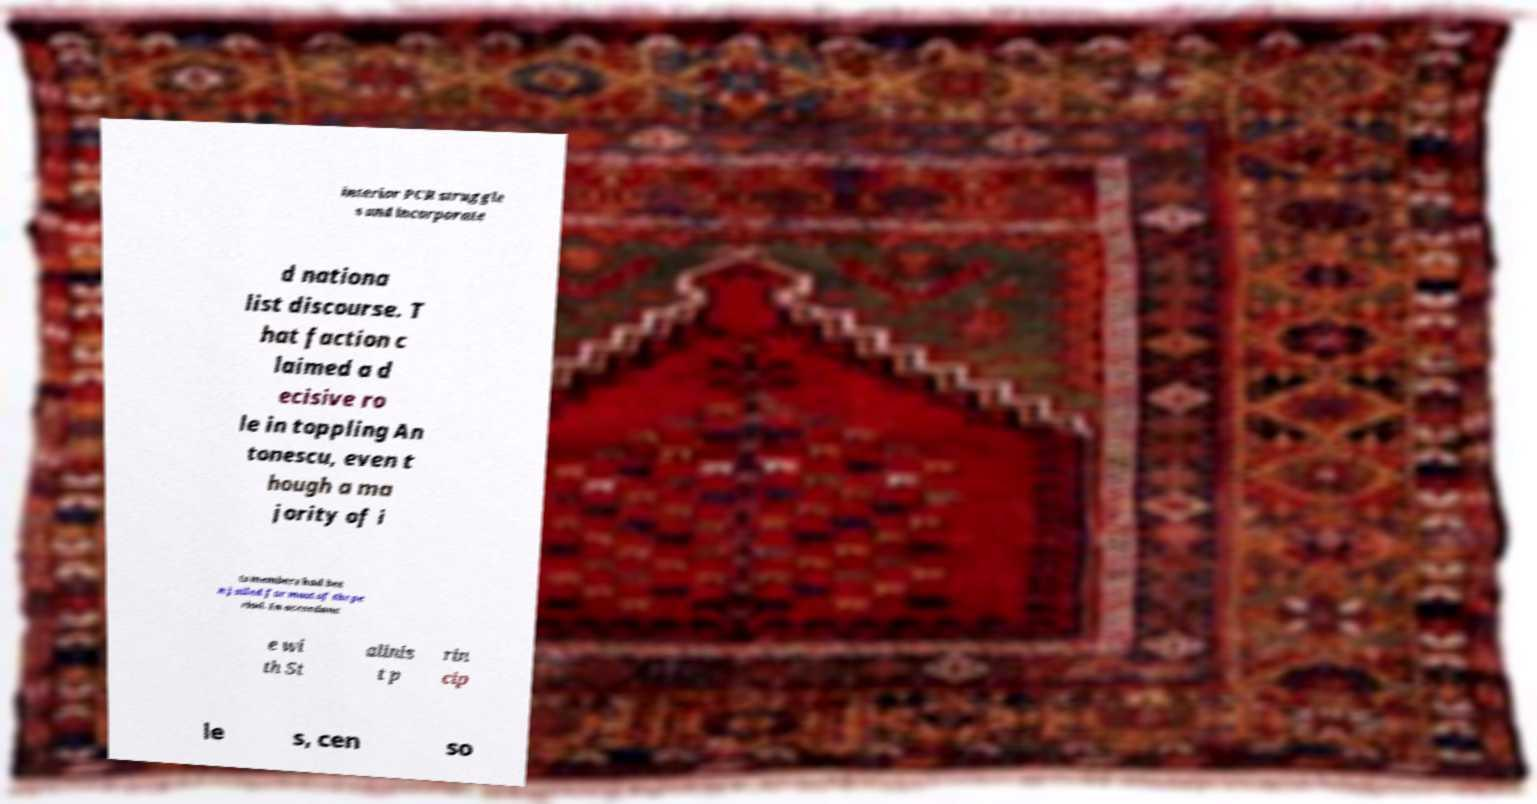Can you accurately transcribe the text from the provided image for me? interior PCR struggle s and incorporate d nationa list discourse. T hat faction c laimed a d ecisive ro le in toppling An tonescu, even t hough a ma jority of i ts members had bee n jailed for most of the pe riod. In accordanc e wi th St alinis t p rin cip le s, cen so 